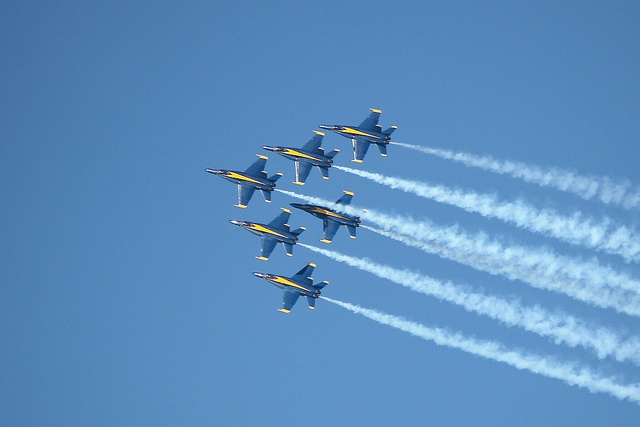Describe the objects in this image and their specific colors. I can see airplane in gray, blue, navy, and lightblue tones, airplane in gray, blue, and navy tones, airplane in gray, blue, and navy tones, airplane in gray, blue, and navy tones, and airplane in gray, blue, and navy tones in this image. 